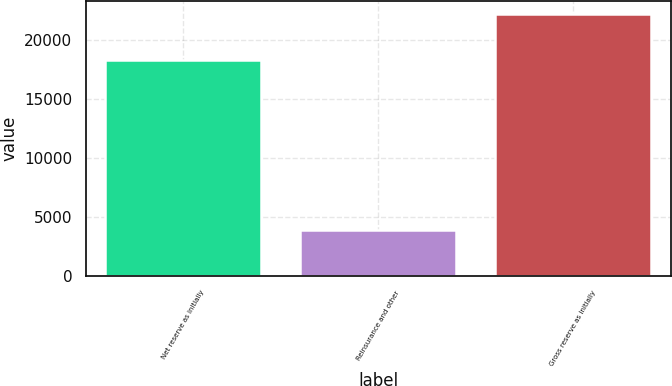<chart> <loc_0><loc_0><loc_500><loc_500><bar_chart><fcel>Net reserve as initially<fcel>Reinsurance and other<fcel>Gross reserve as initially<nl><fcel>18231<fcel>3922<fcel>22153<nl></chart> 